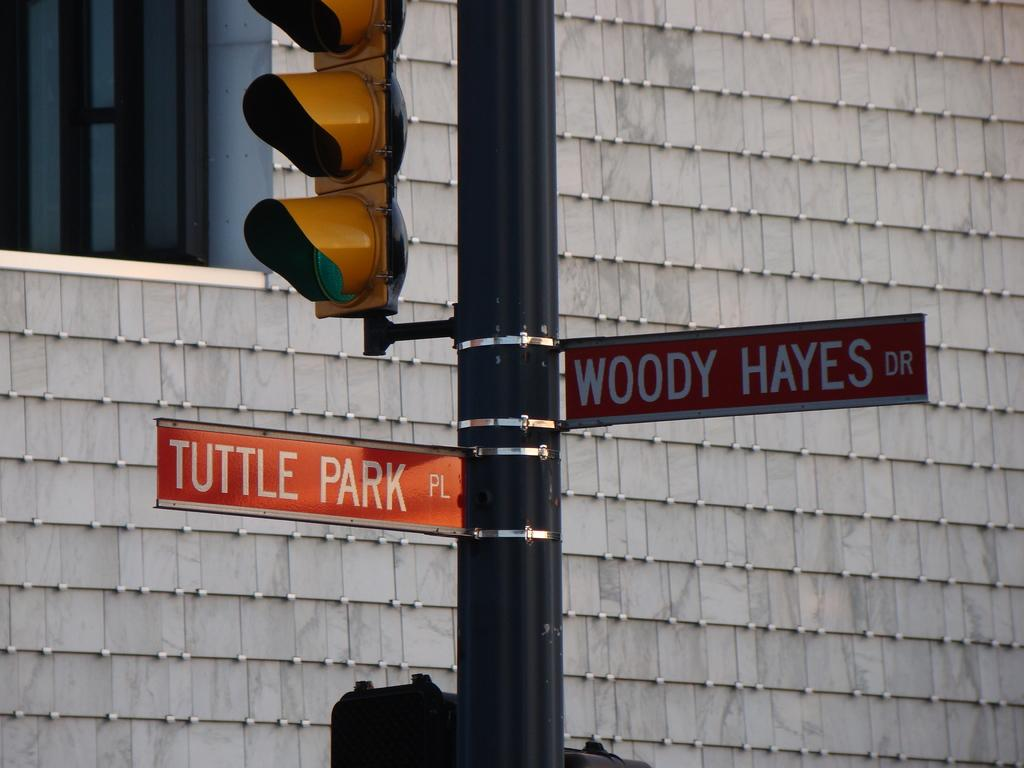What is the main object in the middle of the image? There is a pole in the middle of the image. What is attached to the pole? A name board and a traffic light are present on the pole. What can be seen behind the pole? There is a wall behind the pole. What architectural feature is visible on the wall? There is a window on the left side of the wall. What type of powder is being used to clean the pole in the image? There is no indication of any cleaning activity or powder present in the image. 